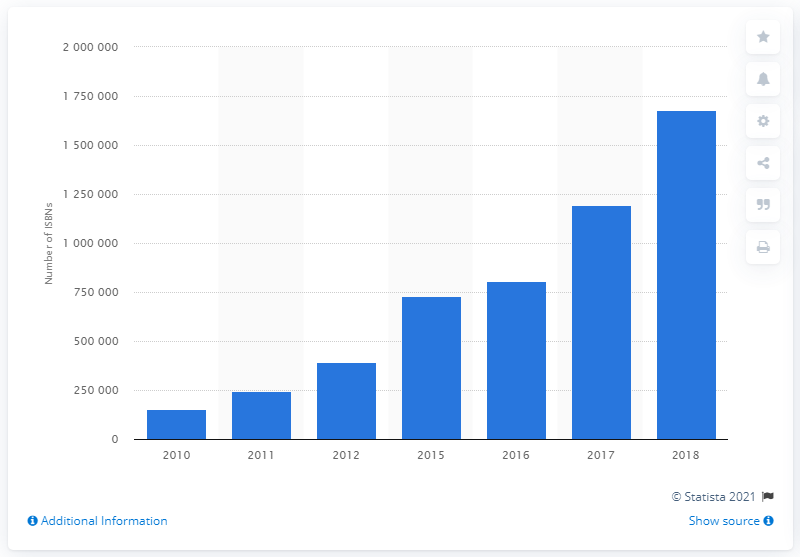Mention a couple of crucial points in this snapshot. In 2017, 119,234 ISBNs were assigned to self-published books in the United States. In 2018, a total of 1677781 ISBNs were assigned to self-published books in the United States. 